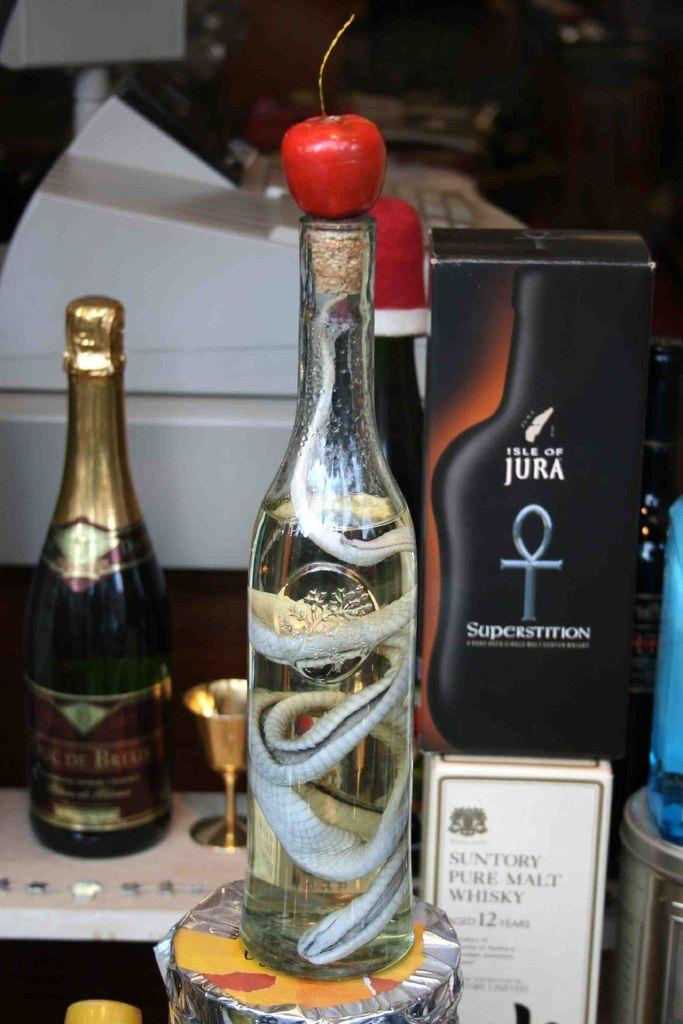<image>
Share a concise interpretation of the image provided. A bottle of Superstition alcohol from the Isle of Jura. 